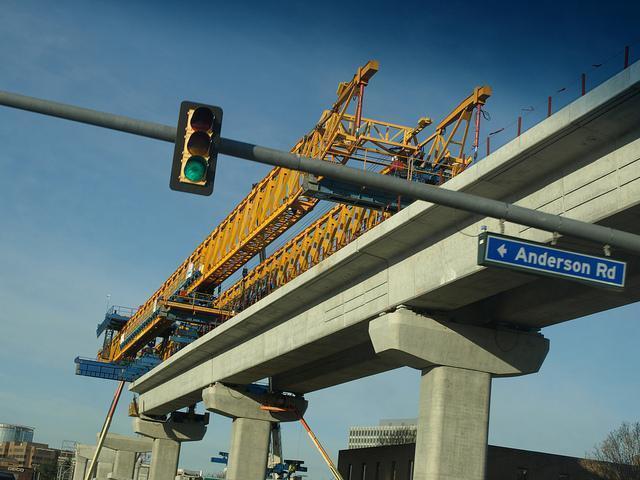How many traffic lights are in the picture?
Give a very brief answer. 1. How many beds are in the room?
Give a very brief answer. 0. 